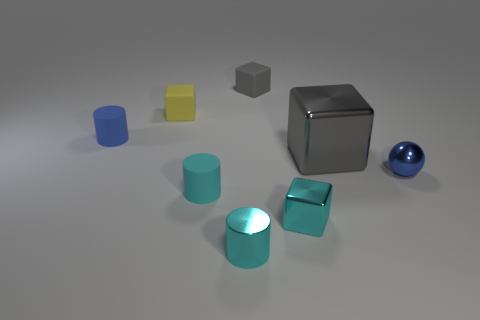Subtract 1 blocks. How many blocks are left? 3 Subtract all purple cubes. Subtract all purple cylinders. How many cubes are left? 4 Add 1 yellow blocks. How many objects exist? 9 Subtract all spheres. How many objects are left? 7 Subtract 0 brown spheres. How many objects are left? 8 Subtract all rubber blocks. Subtract all yellow objects. How many objects are left? 5 Add 7 cyan cylinders. How many cyan cylinders are left? 9 Add 8 blue metallic spheres. How many blue metallic spheres exist? 9 